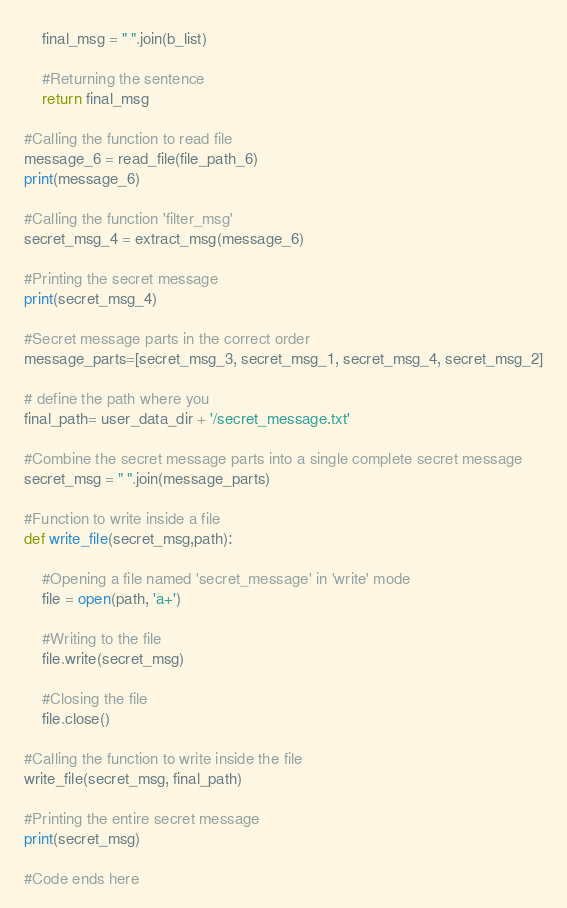<code> <loc_0><loc_0><loc_500><loc_500><_Python_>    final_msg = " ".join(b_list)
    
    #Returning the sentence
    return final_msg
    
#Calling the function to read file
message_6 = read_file(file_path_6)
print(message_6)

#Calling the function 'filter_msg'
secret_msg_4 = extract_msg(message_6)

#Printing the secret message
print(secret_msg_4)

#Secret message parts in the correct order
message_parts=[secret_msg_3, secret_msg_1, secret_msg_4, secret_msg_2]

# define the path where you 
final_path= user_data_dir + '/secret_message.txt'

#Combine the secret message parts into a single complete secret message
secret_msg = " ".join(message_parts)

#Function to write inside a file
def write_file(secret_msg,path):
       
    #Opening a file named 'secret_message' in 'write' mode
    file = open(path, 'a+')

    #Writing to the file
    file.write(secret_msg)

    #Closing the file
    file.close()

#Calling the function to write inside the file    
write_file(secret_msg, final_path)

#Printing the entire secret message
print(secret_msg)

#Code ends here


</code> 